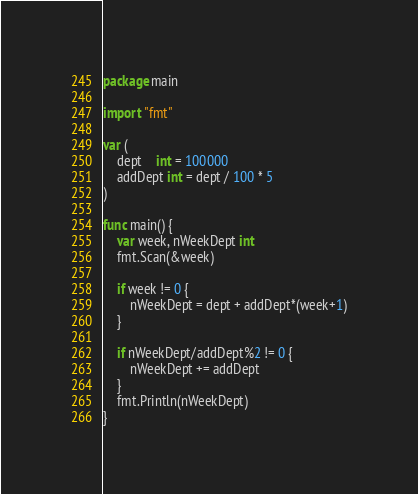Convert code to text. <code><loc_0><loc_0><loc_500><loc_500><_Go_>package main

import "fmt"

var (
	dept    int = 100000
	addDept int = dept / 100 * 5
)

func main() {
	var week, nWeekDept int
	fmt.Scan(&week)

	if week != 0 {
		nWeekDept = dept + addDept*(week+1)
	}

	if nWeekDept/addDept%2 != 0 {
		nWeekDept += addDept
	}
	fmt.Println(nWeekDept)
}


</code> 